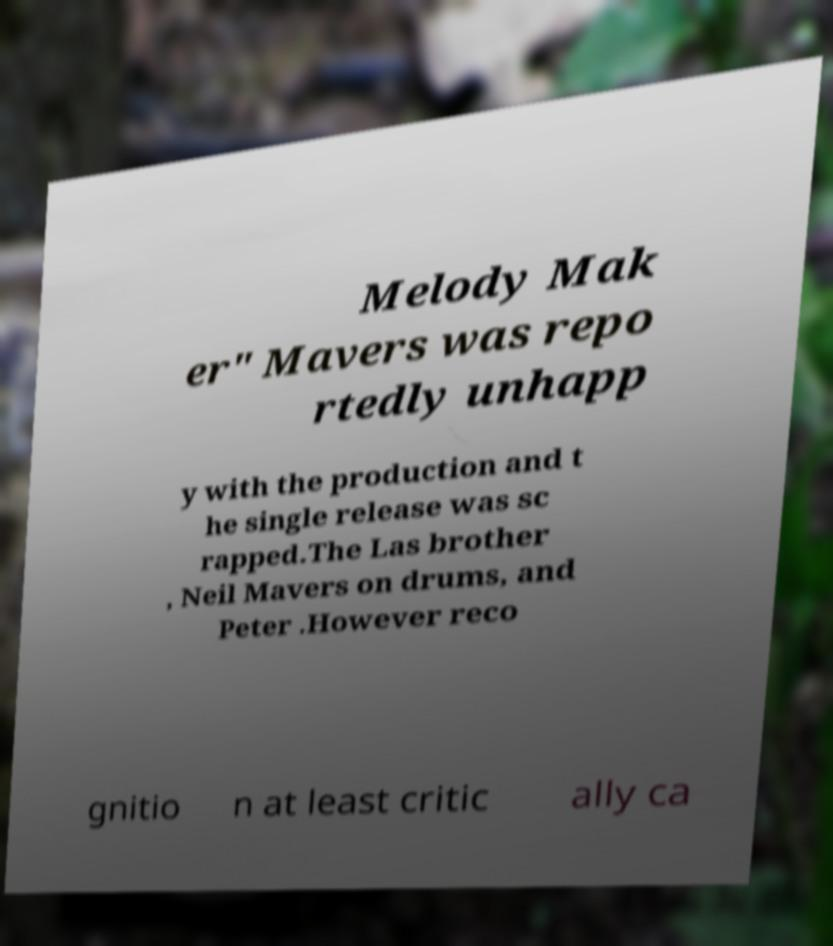There's text embedded in this image that I need extracted. Can you transcribe it verbatim? Melody Mak er" Mavers was repo rtedly unhapp y with the production and t he single release was sc rapped.The Las brother , Neil Mavers on drums, and Peter .However reco gnitio n at least critic ally ca 